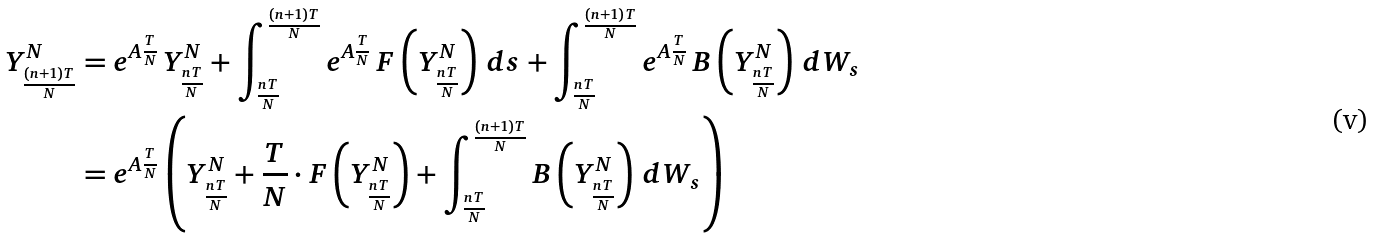Convert formula to latex. <formula><loc_0><loc_0><loc_500><loc_500>Y ^ { N } _ { \frac { ( n + 1 ) T } { N } } & = e ^ { A \frac { T } { N } } \, Y ^ { N } _ { \frac { n T } { N } } + \int _ { \frac { n T } { N } } ^ { \frac { ( n + 1 ) T } { N } } e ^ { A \frac { T } { N } } \, F \left ( Y ^ { N } _ { \frac { n T } { N } } \right ) \, d s + \int _ { \frac { n T } { N } } ^ { \frac { ( n + 1 ) T } { N } } e ^ { A \frac { T } { N } } \, B \left ( Y ^ { N } _ { \frac { n T } { N } } \right ) \, d W _ { s } \\ & = e ^ { A \frac { T } { N } } \left ( Y ^ { N } _ { \frac { n T } { N } } + \frac { T } { N } \cdot F \left ( Y ^ { N } _ { \frac { n T } { N } } \right ) + \int _ { \frac { n T } { N } } ^ { \frac { ( n + 1 ) T } { N } } B \left ( Y ^ { N } _ { \frac { n T } { N } } \right ) \, d W _ { s } \right )</formula> 